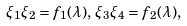Convert formula to latex. <formula><loc_0><loc_0><loc_500><loc_500>\xi _ { 1 } \xi _ { 2 } = f _ { 1 } ( \lambda ) , \, \xi _ { 3 } \xi _ { 4 } = f _ { 2 } ( \lambda ) ,</formula> 